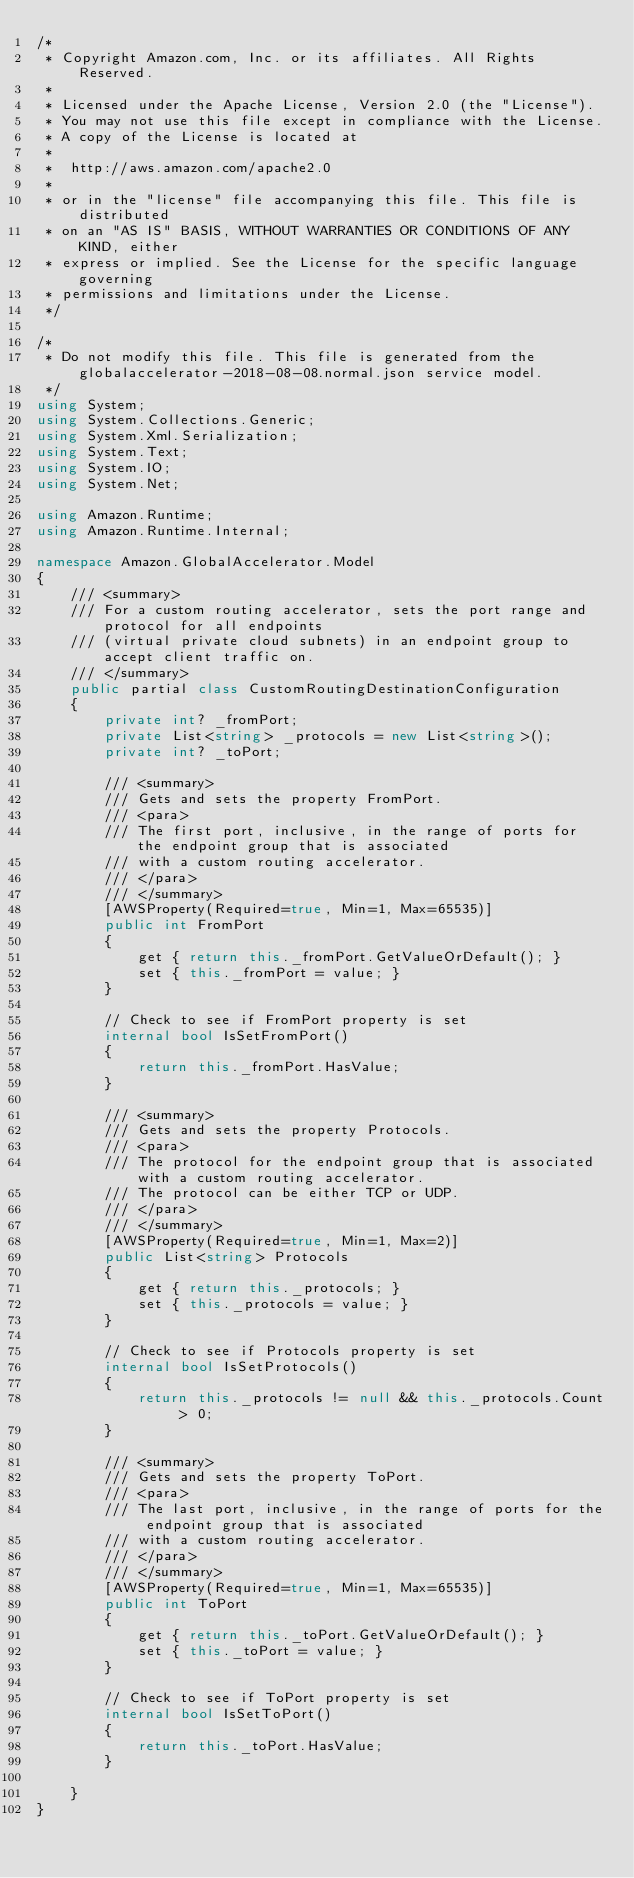Convert code to text. <code><loc_0><loc_0><loc_500><loc_500><_C#_>/*
 * Copyright Amazon.com, Inc. or its affiliates. All Rights Reserved.
 * 
 * Licensed under the Apache License, Version 2.0 (the "License").
 * You may not use this file except in compliance with the License.
 * A copy of the License is located at
 * 
 *  http://aws.amazon.com/apache2.0
 * 
 * or in the "license" file accompanying this file. This file is distributed
 * on an "AS IS" BASIS, WITHOUT WARRANTIES OR CONDITIONS OF ANY KIND, either
 * express or implied. See the License for the specific language governing
 * permissions and limitations under the License.
 */

/*
 * Do not modify this file. This file is generated from the globalaccelerator-2018-08-08.normal.json service model.
 */
using System;
using System.Collections.Generic;
using System.Xml.Serialization;
using System.Text;
using System.IO;
using System.Net;

using Amazon.Runtime;
using Amazon.Runtime.Internal;

namespace Amazon.GlobalAccelerator.Model
{
    /// <summary>
    /// For a custom routing accelerator, sets the port range and protocol for all endpoints
    /// (virtual private cloud subnets) in an endpoint group to accept client traffic on.
    /// </summary>
    public partial class CustomRoutingDestinationConfiguration
    {
        private int? _fromPort;
        private List<string> _protocols = new List<string>();
        private int? _toPort;

        /// <summary>
        /// Gets and sets the property FromPort. 
        /// <para>
        /// The first port, inclusive, in the range of ports for the endpoint group that is associated
        /// with a custom routing accelerator.
        /// </para>
        /// </summary>
        [AWSProperty(Required=true, Min=1, Max=65535)]
        public int FromPort
        {
            get { return this._fromPort.GetValueOrDefault(); }
            set { this._fromPort = value; }
        }

        // Check to see if FromPort property is set
        internal bool IsSetFromPort()
        {
            return this._fromPort.HasValue; 
        }

        /// <summary>
        /// Gets and sets the property Protocols. 
        /// <para>
        /// The protocol for the endpoint group that is associated with a custom routing accelerator.
        /// The protocol can be either TCP or UDP.
        /// </para>
        /// </summary>
        [AWSProperty(Required=true, Min=1, Max=2)]
        public List<string> Protocols
        {
            get { return this._protocols; }
            set { this._protocols = value; }
        }

        // Check to see if Protocols property is set
        internal bool IsSetProtocols()
        {
            return this._protocols != null && this._protocols.Count > 0; 
        }

        /// <summary>
        /// Gets and sets the property ToPort. 
        /// <para>
        /// The last port, inclusive, in the range of ports for the endpoint group that is associated
        /// with a custom routing accelerator.
        /// </para>
        /// </summary>
        [AWSProperty(Required=true, Min=1, Max=65535)]
        public int ToPort
        {
            get { return this._toPort.GetValueOrDefault(); }
            set { this._toPort = value; }
        }

        // Check to see if ToPort property is set
        internal bool IsSetToPort()
        {
            return this._toPort.HasValue; 
        }

    }
}</code> 